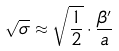<formula> <loc_0><loc_0><loc_500><loc_500>\sqrt { \sigma } \approx \sqrt { \frac { 1 } { 2 } } \cdot \frac { \beta ^ { \prime } } a</formula> 